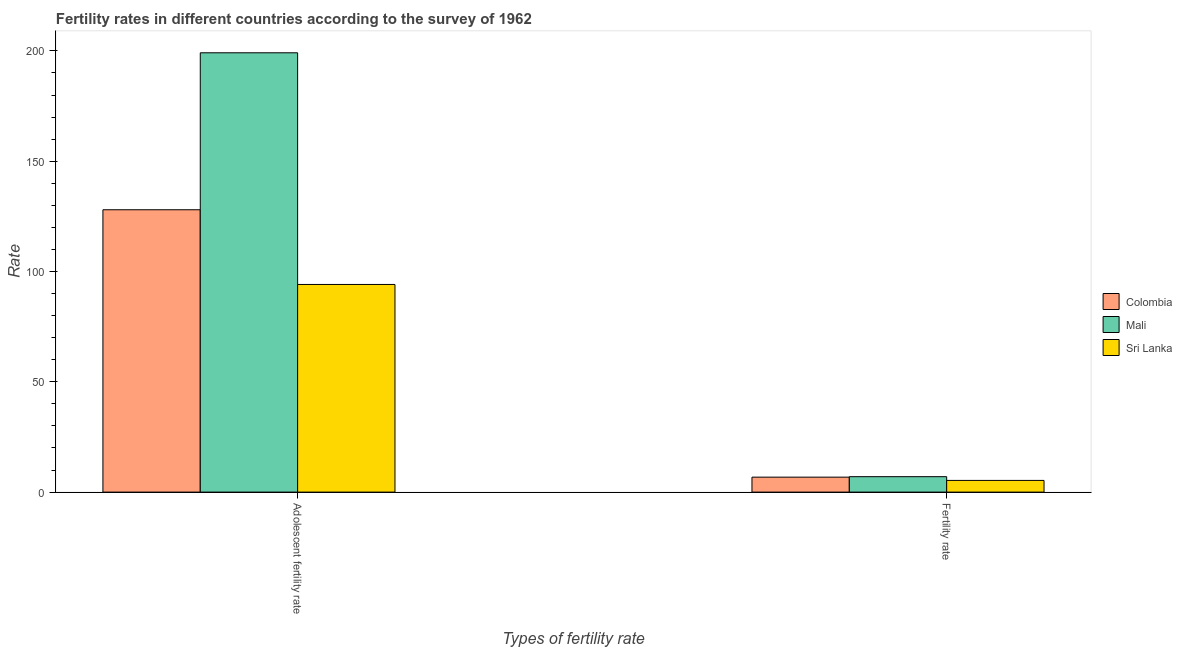How many groups of bars are there?
Offer a terse response. 2. Are the number of bars on each tick of the X-axis equal?
Offer a very short reply. Yes. What is the label of the 1st group of bars from the left?
Give a very brief answer. Adolescent fertility rate. What is the adolescent fertility rate in Colombia?
Offer a terse response. 127.99. Across all countries, what is the maximum adolescent fertility rate?
Give a very brief answer. 199.15. Across all countries, what is the minimum fertility rate?
Offer a very short reply. 5.3. In which country was the adolescent fertility rate maximum?
Make the answer very short. Mali. In which country was the fertility rate minimum?
Your answer should be compact. Sri Lanka. What is the total adolescent fertility rate in the graph?
Your answer should be compact. 421.27. What is the difference between the adolescent fertility rate in Sri Lanka and that in Colombia?
Provide a succinct answer. -33.86. What is the difference between the adolescent fertility rate in Sri Lanka and the fertility rate in Mali?
Ensure brevity in your answer.  87.14. What is the average fertility rate per country?
Offer a very short reply. 6.36. What is the difference between the fertility rate and adolescent fertility rate in Colombia?
Make the answer very short. -121.22. In how many countries, is the fertility rate greater than 20 ?
Your answer should be compact. 0. What is the ratio of the adolescent fertility rate in Sri Lanka to that in Colombia?
Your answer should be compact. 0.74. How many bars are there?
Provide a succinct answer. 6. Are all the bars in the graph horizontal?
Keep it short and to the point. No. How many countries are there in the graph?
Provide a succinct answer. 3. Are the values on the major ticks of Y-axis written in scientific E-notation?
Provide a succinct answer. No. Where does the legend appear in the graph?
Offer a very short reply. Center right. How are the legend labels stacked?
Offer a very short reply. Vertical. What is the title of the graph?
Ensure brevity in your answer.  Fertility rates in different countries according to the survey of 1962. What is the label or title of the X-axis?
Your response must be concise. Types of fertility rate. What is the label or title of the Y-axis?
Keep it short and to the point. Rate. What is the Rate in Colombia in Adolescent fertility rate?
Ensure brevity in your answer.  127.99. What is the Rate of Mali in Adolescent fertility rate?
Make the answer very short. 199.15. What is the Rate of Sri Lanka in Adolescent fertility rate?
Make the answer very short. 94.13. What is the Rate in Colombia in Fertility rate?
Offer a terse response. 6.78. What is the Rate in Mali in Fertility rate?
Offer a very short reply. 6.99. What is the Rate of Sri Lanka in Fertility rate?
Your response must be concise. 5.3. Across all Types of fertility rate, what is the maximum Rate of Colombia?
Provide a succinct answer. 127.99. Across all Types of fertility rate, what is the maximum Rate in Mali?
Your answer should be compact. 199.15. Across all Types of fertility rate, what is the maximum Rate in Sri Lanka?
Give a very brief answer. 94.13. Across all Types of fertility rate, what is the minimum Rate in Colombia?
Ensure brevity in your answer.  6.78. Across all Types of fertility rate, what is the minimum Rate in Mali?
Offer a terse response. 6.99. Across all Types of fertility rate, what is the minimum Rate in Sri Lanka?
Give a very brief answer. 5.3. What is the total Rate in Colombia in the graph?
Ensure brevity in your answer.  134.77. What is the total Rate of Mali in the graph?
Offer a terse response. 206.14. What is the total Rate in Sri Lanka in the graph?
Ensure brevity in your answer.  99.43. What is the difference between the Rate of Colombia in Adolescent fertility rate and that in Fertility rate?
Make the answer very short. 121.22. What is the difference between the Rate in Mali in Adolescent fertility rate and that in Fertility rate?
Make the answer very short. 192.15. What is the difference between the Rate in Sri Lanka in Adolescent fertility rate and that in Fertility rate?
Your answer should be compact. 88.83. What is the difference between the Rate of Colombia in Adolescent fertility rate and the Rate of Mali in Fertility rate?
Your response must be concise. 121. What is the difference between the Rate in Colombia in Adolescent fertility rate and the Rate in Sri Lanka in Fertility rate?
Ensure brevity in your answer.  122.69. What is the difference between the Rate in Mali in Adolescent fertility rate and the Rate in Sri Lanka in Fertility rate?
Provide a succinct answer. 193.85. What is the average Rate of Colombia per Types of fertility rate?
Offer a very short reply. 67.39. What is the average Rate in Mali per Types of fertility rate?
Your answer should be compact. 103.07. What is the average Rate of Sri Lanka per Types of fertility rate?
Your answer should be compact. 49.71. What is the difference between the Rate of Colombia and Rate of Mali in Adolescent fertility rate?
Keep it short and to the point. -71.15. What is the difference between the Rate in Colombia and Rate in Sri Lanka in Adolescent fertility rate?
Offer a very short reply. 33.86. What is the difference between the Rate in Mali and Rate in Sri Lanka in Adolescent fertility rate?
Make the answer very short. 105.02. What is the difference between the Rate of Colombia and Rate of Mali in Fertility rate?
Give a very brief answer. -0.21. What is the difference between the Rate of Colombia and Rate of Sri Lanka in Fertility rate?
Make the answer very short. 1.48. What is the difference between the Rate of Mali and Rate of Sri Lanka in Fertility rate?
Keep it short and to the point. 1.7. What is the ratio of the Rate of Colombia in Adolescent fertility rate to that in Fertility rate?
Give a very brief answer. 18.88. What is the ratio of the Rate in Mali in Adolescent fertility rate to that in Fertility rate?
Provide a short and direct response. 28.47. What is the ratio of the Rate in Sri Lanka in Adolescent fertility rate to that in Fertility rate?
Make the answer very short. 17.76. What is the difference between the highest and the second highest Rate in Colombia?
Your answer should be very brief. 121.22. What is the difference between the highest and the second highest Rate of Mali?
Make the answer very short. 192.15. What is the difference between the highest and the second highest Rate in Sri Lanka?
Your answer should be very brief. 88.83. What is the difference between the highest and the lowest Rate of Colombia?
Provide a short and direct response. 121.22. What is the difference between the highest and the lowest Rate of Mali?
Make the answer very short. 192.15. What is the difference between the highest and the lowest Rate of Sri Lanka?
Make the answer very short. 88.83. 